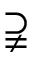Convert formula to latex. <formula><loc_0><loc_0><loc_500><loc_500>\supsetneqq</formula> 